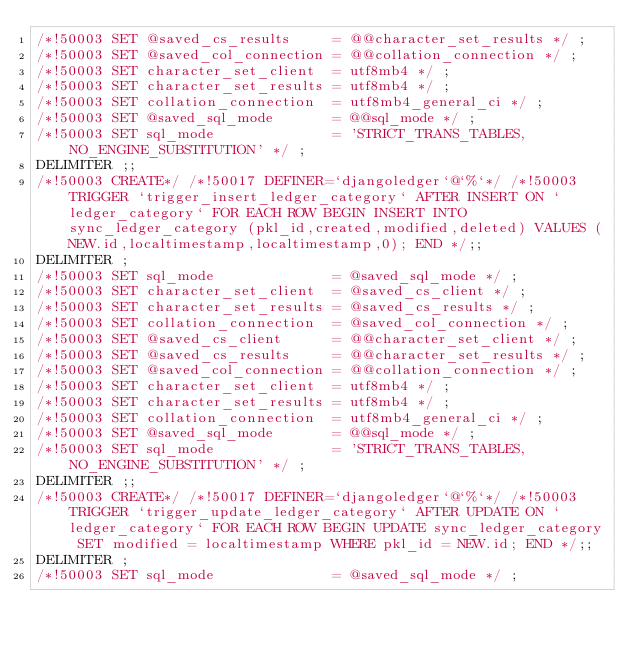Convert code to text. <code><loc_0><loc_0><loc_500><loc_500><_SQL_>/*!50003 SET @saved_cs_results     = @@character_set_results */ ;
/*!50003 SET @saved_col_connection = @@collation_connection */ ;
/*!50003 SET character_set_client  = utf8mb4 */ ;
/*!50003 SET character_set_results = utf8mb4 */ ;
/*!50003 SET collation_connection  = utf8mb4_general_ci */ ;
/*!50003 SET @saved_sql_mode       = @@sql_mode */ ;
/*!50003 SET sql_mode              = 'STRICT_TRANS_TABLES,NO_ENGINE_SUBSTITUTION' */ ;
DELIMITER ;;
/*!50003 CREATE*/ /*!50017 DEFINER=`djangoledger`@`%`*/ /*!50003 TRIGGER `trigger_insert_ledger_category` AFTER INSERT ON `ledger_category` FOR EACH ROW BEGIN INSERT INTO sync_ledger_category (pkl_id,created,modified,deleted) VALUES (NEW.id,localtimestamp,localtimestamp,0); END */;;
DELIMITER ;
/*!50003 SET sql_mode              = @saved_sql_mode */ ;
/*!50003 SET character_set_client  = @saved_cs_client */ ;
/*!50003 SET character_set_results = @saved_cs_results */ ;
/*!50003 SET collation_connection  = @saved_col_connection */ ;
/*!50003 SET @saved_cs_client      = @@character_set_client */ ;
/*!50003 SET @saved_cs_results     = @@character_set_results */ ;
/*!50003 SET @saved_col_connection = @@collation_connection */ ;
/*!50003 SET character_set_client  = utf8mb4 */ ;
/*!50003 SET character_set_results = utf8mb4 */ ;
/*!50003 SET collation_connection  = utf8mb4_general_ci */ ;
/*!50003 SET @saved_sql_mode       = @@sql_mode */ ;
/*!50003 SET sql_mode              = 'STRICT_TRANS_TABLES,NO_ENGINE_SUBSTITUTION' */ ;
DELIMITER ;;
/*!50003 CREATE*/ /*!50017 DEFINER=`djangoledger`@`%`*/ /*!50003 TRIGGER `trigger_update_ledger_category` AFTER UPDATE ON `ledger_category` FOR EACH ROW BEGIN UPDATE sync_ledger_category SET modified = localtimestamp WHERE pkl_id = NEW.id; END */;;
DELIMITER ;
/*!50003 SET sql_mode              = @saved_sql_mode */ ;</code> 